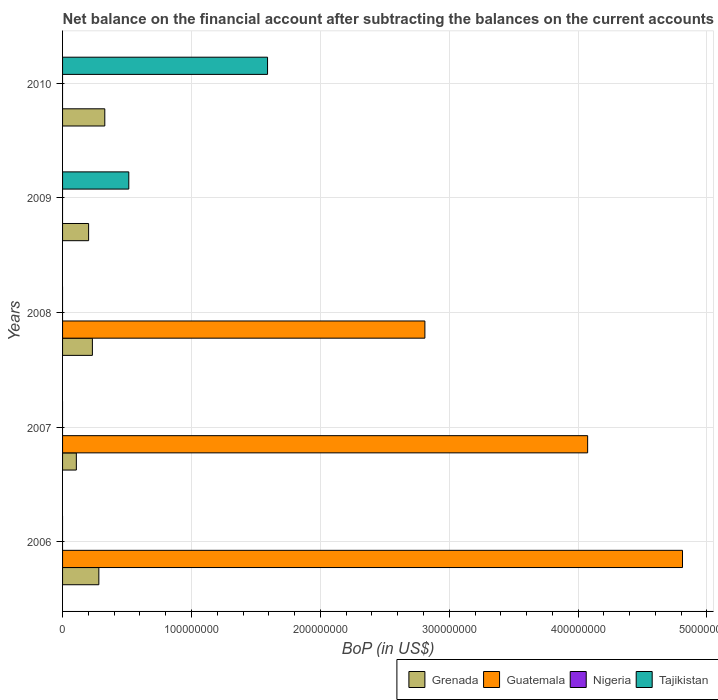How many different coloured bars are there?
Offer a terse response. 3. How many groups of bars are there?
Provide a short and direct response. 5. Are the number of bars on each tick of the Y-axis equal?
Offer a terse response. Yes. How many bars are there on the 3rd tick from the top?
Your answer should be compact. 2. How many bars are there on the 1st tick from the bottom?
Give a very brief answer. 2. In how many cases, is the number of bars for a given year not equal to the number of legend labels?
Offer a terse response. 5. Across all years, what is the maximum Balance of Payments in Grenada?
Offer a very short reply. 3.28e+07. In which year was the Balance of Payments in Grenada maximum?
Make the answer very short. 2010. What is the difference between the Balance of Payments in Guatemala in 2006 and that in 2007?
Your answer should be very brief. 7.36e+07. What is the difference between the Balance of Payments in Guatemala in 2009 and the Balance of Payments in Grenada in 2008?
Your answer should be very brief. -2.31e+07. In the year 2008, what is the difference between the Balance of Payments in Grenada and Balance of Payments in Guatemala?
Your answer should be compact. -2.58e+08. What is the ratio of the Balance of Payments in Grenada in 2007 to that in 2008?
Keep it short and to the point. 0.46. Is the Balance of Payments in Guatemala in 2007 less than that in 2008?
Ensure brevity in your answer.  No. Is the difference between the Balance of Payments in Grenada in 2006 and 2007 greater than the difference between the Balance of Payments in Guatemala in 2006 and 2007?
Provide a short and direct response. No. What is the difference between the highest and the second highest Balance of Payments in Guatemala?
Keep it short and to the point. 7.36e+07. What is the difference between the highest and the lowest Balance of Payments in Tajikistan?
Provide a short and direct response. 1.59e+08. In how many years, is the Balance of Payments in Grenada greater than the average Balance of Payments in Grenada taken over all years?
Keep it short and to the point. 3. Is the sum of the Balance of Payments in Grenada in 2007 and 2009 greater than the maximum Balance of Payments in Nigeria across all years?
Make the answer very short. Yes. Is it the case that in every year, the sum of the Balance of Payments in Tajikistan and Balance of Payments in Nigeria is greater than the sum of Balance of Payments in Guatemala and Balance of Payments in Grenada?
Give a very brief answer. No. How many bars are there?
Provide a short and direct response. 10. Are all the bars in the graph horizontal?
Your answer should be compact. Yes. What is the difference between two consecutive major ticks on the X-axis?
Offer a terse response. 1.00e+08. Does the graph contain any zero values?
Provide a short and direct response. Yes. Does the graph contain grids?
Your response must be concise. Yes. How are the legend labels stacked?
Your response must be concise. Horizontal. What is the title of the graph?
Provide a short and direct response. Net balance on the financial account after subtracting the balances on the current accounts. Does "Sub-Saharan Africa (all income levels)" appear as one of the legend labels in the graph?
Give a very brief answer. No. What is the label or title of the X-axis?
Provide a succinct answer. BoP (in US$). What is the label or title of the Y-axis?
Offer a very short reply. Years. What is the BoP (in US$) in Grenada in 2006?
Your answer should be very brief. 2.82e+07. What is the BoP (in US$) in Guatemala in 2006?
Offer a very short reply. 4.81e+08. What is the BoP (in US$) in Nigeria in 2006?
Give a very brief answer. 0. What is the BoP (in US$) in Grenada in 2007?
Your answer should be very brief. 1.07e+07. What is the BoP (in US$) of Guatemala in 2007?
Offer a terse response. 4.07e+08. What is the BoP (in US$) in Grenada in 2008?
Offer a very short reply. 2.31e+07. What is the BoP (in US$) of Guatemala in 2008?
Your answer should be very brief. 2.81e+08. What is the BoP (in US$) in Nigeria in 2008?
Ensure brevity in your answer.  0. What is the BoP (in US$) in Tajikistan in 2008?
Your response must be concise. 0. What is the BoP (in US$) of Grenada in 2009?
Give a very brief answer. 2.02e+07. What is the BoP (in US$) in Guatemala in 2009?
Your response must be concise. 0. What is the BoP (in US$) in Nigeria in 2009?
Make the answer very short. 0. What is the BoP (in US$) of Tajikistan in 2009?
Offer a terse response. 5.14e+07. What is the BoP (in US$) in Grenada in 2010?
Ensure brevity in your answer.  3.28e+07. What is the BoP (in US$) in Nigeria in 2010?
Provide a succinct answer. 0. What is the BoP (in US$) in Tajikistan in 2010?
Give a very brief answer. 1.59e+08. Across all years, what is the maximum BoP (in US$) of Grenada?
Your answer should be very brief. 3.28e+07. Across all years, what is the maximum BoP (in US$) of Guatemala?
Provide a short and direct response. 4.81e+08. Across all years, what is the maximum BoP (in US$) in Tajikistan?
Provide a short and direct response. 1.59e+08. Across all years, what is the minimum BoP (in US$) of Grenada?
Provide a short and direct response. 1.07e+07. Across all years, what is the minimum BoP (in US$) of Guatemala?
Offer a very short reply. 0. What is the total BoP (in US$) in Grenada in the graph?
Your answer should be very brief. 1.15e+08. What is the total BoP (in US$) of Guatemala in the graph?
Provide a short and direct response. 1.17e+09. What is the total BoP (in US$) of Nigeria in the graph?
Offer a very short reply. 0. What is the total BoP (in US$) in Tajikistan in the graph?
Provide a succinct answer. 2.10e+08. What is the difference between the BoP (in US$) of Grenada in 2006 and that in 2007?
Keep it short and to the point. 1.75e+07. What is the difference between the BoP (in US$) in Guatemala in 2006 and that in 2007?
Offer a terse response. 7.36e+07. What is the difference between the BoP (in US$) of Grenada in 2006 and that in 2008?
Give a very brief answer. 5.01e+06. What is the difference between the BoP (in US$) in Guatemala in 2006 and that in 2008?
Offer a very short reply. 2.00e+08. What is the difference between the BoP (in US$) in Grenada in 2006 and that in 2009?
Your answer should be compact. 7.95e+06. What is the difference between the BoP (in US$) in Grenada in 2006 and that in 2010?
Ensure brevity in your answer.  -4.61e+06. What is the difference between the BoP (in US$) of Grenada in 2007 and that in 2008?
Your answer should be very brief. -1.25e+07. What is the difference between the BoP (in US$) of Guatemala in 2007 and that in 2008?
Provide a short and direct response. 1.26e+08. What is the difference between the BoP (in US$) in Grenada in 2007 and that in 2009?
Your response must be concise. -9.51e+06. What is the difference between the BoP (in US$) of Grenada in 2007 and that in 2010?
Keep it short and to the point. -2.21e+07. What is the difference between the BoP (in US$) of Grenada in 2008 and that in 2009?
Offer a very short reply. 2.94e+06. What is the difference between the BoP (in US$) of Grenada in 2008 and that in 2010?
Ensure brevity in your answer.  -9.62e+06. What is the difference between the BoP (in US$) of Grenada in 2009 and that in 2010?
Offer a terse response. -1.26e+07. What is the difference between the BoP (in US$) of Tajikistan in 2009 and that in 2010?
Keep it short and to the point. -1.08e+08. What is the difference between the BoP (in US$) of Grenada in 2006 and the BoP (in US$) of Guatemala in 2007?
Your response must be concise. -3.79e+08. What is the difference between the BoP (in US$) in Grenada in 2006 and the BoP (in US$) in Guatemala in 2008?
Your response must be concise. -2.53e+08. What is the difference between the BoP (in US$) of Grenada in 2006 and the BoP (in US$) of Tajikistan in 2009?
Provide a short and direct response. -2.32e+07. What is the difference between the BoP (in US$) in Guatemala in 2006 and the BoP (in US$) in Tajikistan in 2009?
Ensure brevity in your answer.  4.30e+08. What is the difference between the BoP (in US$) of Grenada in 2006 and the BoP (in US$) of Tajikistan in 2010?
Offer a terse response. -1.31e+08. What is the difference between the BoP (in US$) in Guatemala in 2006 and the BoP (in US$) in Tajikistan in 2010?
Provide a succinct answer. 3.22e+08. What is the difference between the BoP (in US$) of Grenada in 2007 and the BoP (in US$) of Guatemala in 2008?
Keep it short and to the point. -2.70e+08. What is the difference between the BoP (in US$) in Grenada in 2007 and the BoP (in US$) in Tajikistan in 2009?
Provide a short and direct response. -4.07e+07. What is the difference between the BoP (in US$) of Guatemala in 2007 and the BoP (in US$) of Tajikistan in 2009?
Keep it short and to the point. 3.56e+08. What is the difference between the BoP (in US$) in Grenada in 2007 and the BoP (in US$) in Tajikistan in 2010?
Your answer should be very brief. -1.48e+08. What is the difference between the BoP (in US$) of Guatemala in 2007 and the BoP (in US$) of Tajikistan in 2010?
Offer a very short reply. 2.48e+08. What is the difference between the BoP (in US$) in Grenada in 2008 and the BoP (in US$) in Tajikistan in 2009?
Offer a very short reply. -2.82e+07. What is the difference between the BoP (in US$) of Guatemala in 2008 and the BoP (in US$) of Tajikistan in 2009?
Your answer should be compact. 2.30e+08. What is the difference between the BoP (in US$) of Grenada in 2008 and the BoP (in US$) of Tajikistan in 2010?
Offer a terse response. -1.36e+08. What is the difference between the BoP (in US$) in Guatemala in 2008 and the BoP (in US$) in Tajikistan in 2010?
Provide a succinct answer. 1.22e+08. What is the difference between the BoP (in US$) of Grenada in 2009 and the BoP (in US$) of Tajikistan in 2010?
Offer a very short reply. -1.39e+08. What is the average BoP (in US$) of Grenada per year?
Your response must be concise. 2.30e+07. What is the average BoP (in US$) in Guatemala per year?
Make the answer very short. 2.34e+08. What is the average BoP (in US$) in Nigeria per year?
Provide a short and direct response. 0. What is the average BoP (in US$) of Tajikistan per year?
Offer a very short reply. 4.21e+07. In the year 2006, what is the difference between the BoP (in US$) in Grenada and BoP (in US$) in Guatemala?
Give a very brief answer. -4.53e+08. In the year 2007, what is the difference between the BoP (in US$) of Grenada and BoP (in US$) of Guatemala?
Provide a short and direct response. -3.97e+08. In the year 2008, what is the difference between the BoP (in US$) of Grenada and BoP (in US$) of Guatemala?
Ensure brevity in your answer.  -2.58e+08. In the year 2009, what is the difference between the BoP (in US$) of Grenada and BoP (in US$) of Tajikistan?
Your response must be concise. -3.12e+07. In the year 2010, what is the difference between the BoP (in US$) of Grenada and BoP (in US$) of Tajikistan?
Offer a very short reply. -1.26e+08. What is the ratio of the BoP (in US$) of Grenada in 2006 to that in 2007?
Provide a short and direct response. 2.63. What is the ratio of the BoP (in US$) of Guatemala in 2006 to that in 2007?
Make the answer very short. 1.18. What is the ratio of the BoP (in US$) of Grenada in 2006 to that in 2008?
Ensure brevity in your answer.  1.22. What is the ratio of the BoP (in US$) of Guatemala in 2006 to that in 2008?
Offer a very short reply. 1.71. What is the ratio of the BoP (in US$) of Grenada in 2006 to that in 2009?
Provide a succinct answer. 1.39. What is the ratio of the BoP (in US$) of Grenada in 2006 to that in 2010?
Provide a succinct answer. 0.86. What is the ratio of the BoP (in US$) in Grenada in 2007 to that in 2008?
Your response must be concise. 0.46. What is the ratio of the BoP (in US$) in Guatemala in 2007 to that in 2008?
Keep it short and to the point. 1.45. What is the ratio of the BoP (in US$) of Grenada in 2007 to that in 2009?
Offer a terse response. 0.53. What is the ratio of the BoP (in US$) of Grenada in 2007 to that in 2010?
Offer a very short reply. 0.33. What is the ratio of the BoP (in US$) in Grenada in 2008 to that in 2009?
Make the answer very short. 1.15. What is the ratio of the BoP (in US$) in Grenada in 2008 to that in 2010?
Provide a short and direct response. 0.71. What is the ratio of the BoP (in US$) in Grenada in 2009 to that in 2010?
Your response must be concise. 0.62. What is the ratio of the BoP (in US$) in Tajikistan in 2009 to that in 2010?
Your answer should be very brief. 0.32. What is the difference between the highest and the second highest BoP (in US$) in Grenada?
Provide a short and direct response. 4.61e+06. What is the difference between the highest and the second highest BoP (in US$) of Guatemala?
Your answer should be very brief. 7.36e+07. What is the difference between the highest and the lowest BoP (in US$) of Grenada?
Your answer should be compact. 2.21e+07. What is the difference between the highest and the lowest BoP (in US$) in Guatemala?
Your answer should be very brief. 4.81e+08. What is the difference between the highest and the lowest BoP (in US$) of Tajikistan?
Offer a terse response. 1.59e+08. 